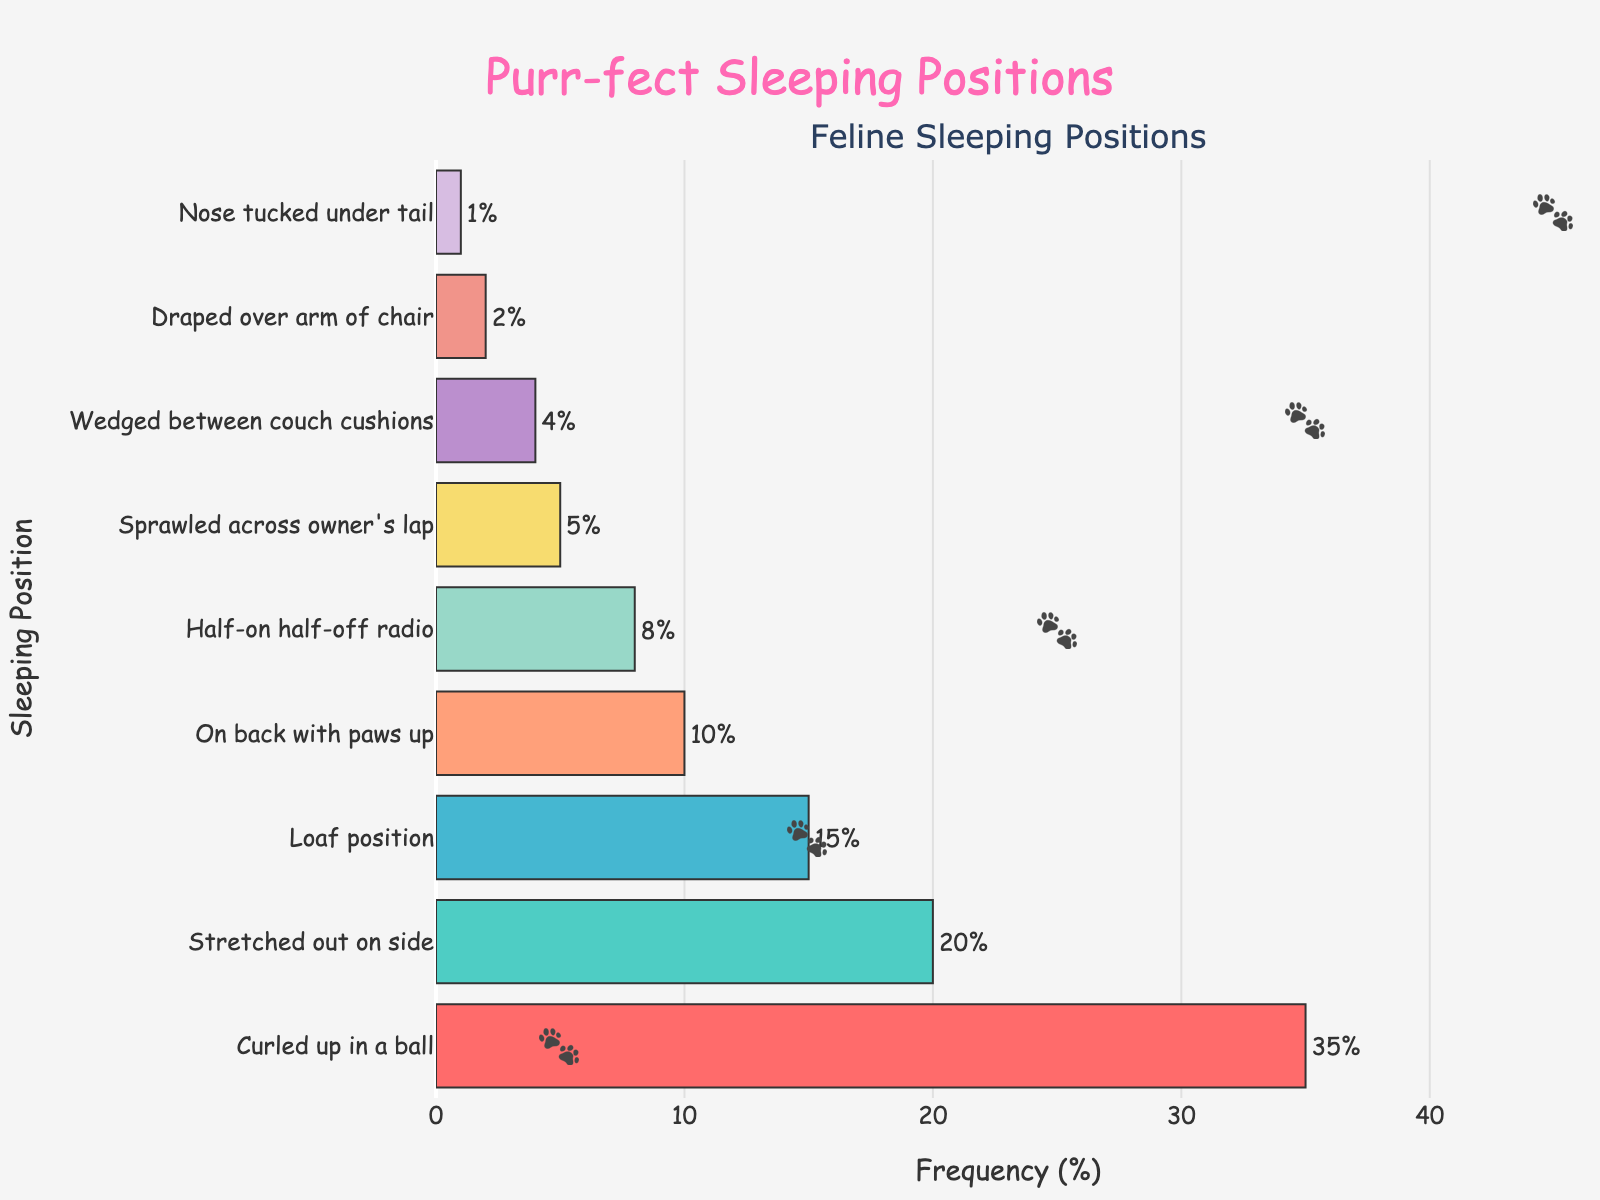Which sleeping position is the most common among domestic cats? The most common sleeping position can be identified by the bar with the highest frequency value. "Curled up in a ball" has the highest frequency value of 35%.
Answer: Curled up in a ball What is the combined frequency of the "Loaf position" and "On back with paws up"? Look at the frequency values for "Loaf position" (15%) and "On back with paws up" (10%). Sum these two values together: 15% + 10% = 25%.
Answer: 25% Which sleeping position has the lowest frequency, and what is its frequency value? The lowest frequency is indicated by the shortest bar. "Nose tucked under tail" has the shortest bar and the frequency value is 1%.
Answer: Nose tucked under tail, 1% How much more common is the "Stretched out on side" position compared to the "Half-on half-off radio" position? Check the frequency values: "Stretched out on side" is 20%, and "Half-on half-off radio" is 8%. Subtract the lower frequency from the higher frequency: 20% - 8% = 12%.
Answer: 12% If a cat has a 50% chance of sleeping in the two most common positions, what are those positions? Identify the two positions with the highest frequency values: "Curled up in a ball" (35%) and "Stretched out on side" (20%). These sum up to 55%, which includes the mentioned 50% chance within these two positions.
Answer: Curled up in a ball and Stretched out on side How many positions have a frequency less than 10%? Identify the bars with values less than 10%: "Half-on half-off radio" (8%), "Sprawled across owner's lap" (5%), "Wedged between couch cushions" (4%), "Draped over arm of chair" (2%), "Nose tucked under tail" (1%). Count these positions.
Answer: 5 What is the difference in frequency between the "Curled up in a ball" position and the sum of "Stretched out on side" and "Loaf position"? The frequency of "Curled up in a ball" is 35%. The sum of "Stretched out on side" (20%) and "Loaf position" (15%) is 35%. Thus, 35% - 35% = 0%.
Answer: 0% Which sleeping position is represented by the color pink in the bar chart? Identify the bar colored pink. The bar legend or the bar directly corresponding under pink is "Curled up in a ball".
Answer: Curled up in a ball What fraction of the total frequency do the three least common positions represent? The frequencies of the three least common positions are: "Draped over arm of chair" (2%), "Wedged between couch cushions" (4%), and "Nose tucked under tail" (1%). Summing these gives 2% + 4% + 1% = 7%. The total frequency is 100%, so the fraction is 7% / 100% = 0.07.
Answer: 0.07 